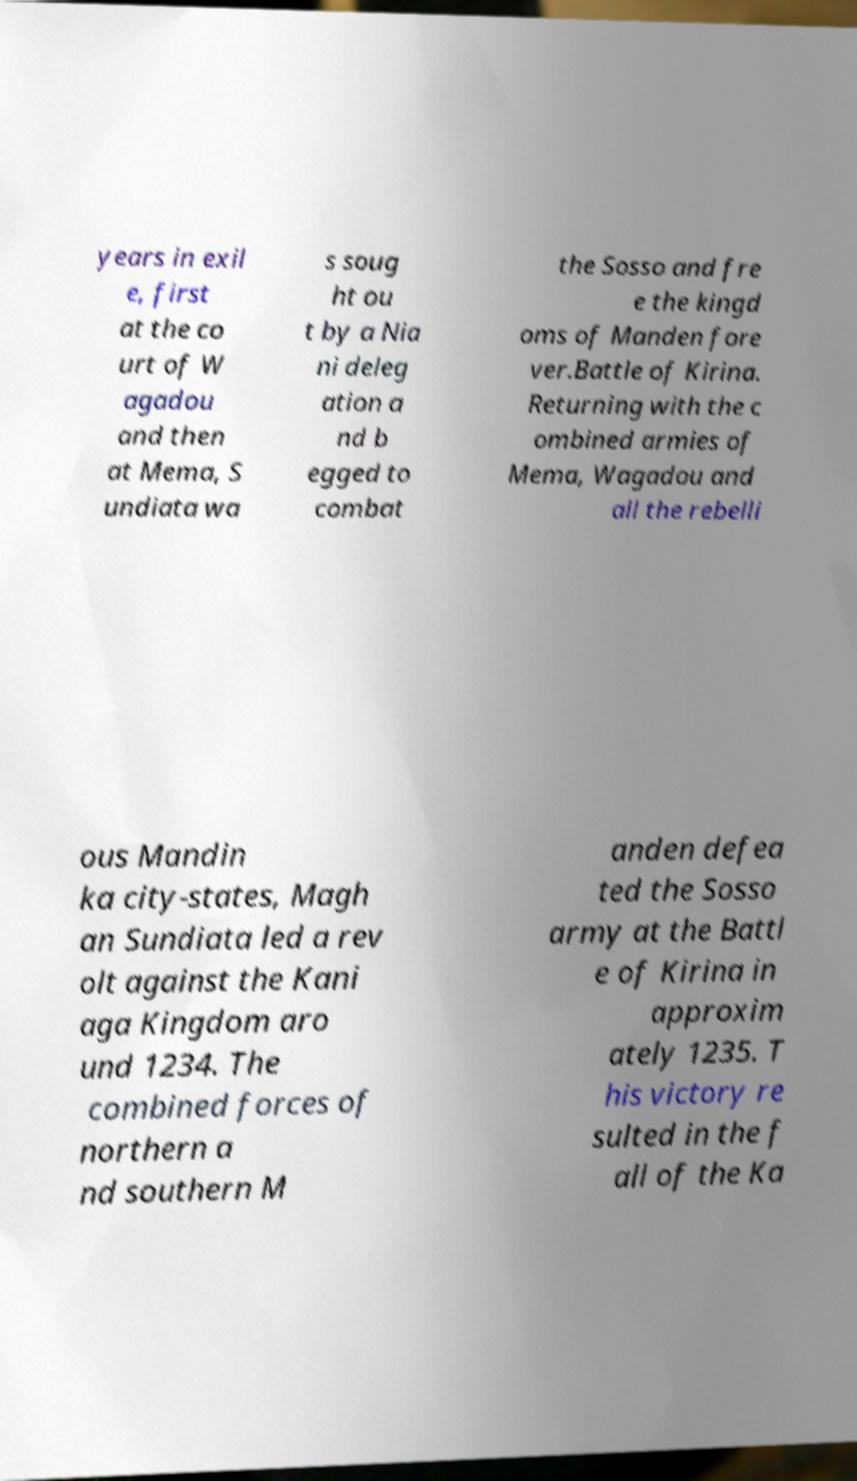Please read and relay the text visible in this image. What does it say? years in exil e, first at the co urt of W agadou and then at Mema, S undiata wa s soug ht ou t by a Nia ni deleg ation a nd b egged to combat the Sosso and fre e the kingd oms of Manden fore ver.Battle of Kirina. Returning with the c ombined armies of Mema, Wagadou and all the rebelli ous Mandin ka city-states, Magh an Sundiata led a rev olt against the Kani aga Kingdom aro und 1234. The combined forces of northern a nd southern M anden defea ted the Sosso army at the Battl e of Kirina in approxim ately 1235. T his victory re sulted in the f all of the Ka 